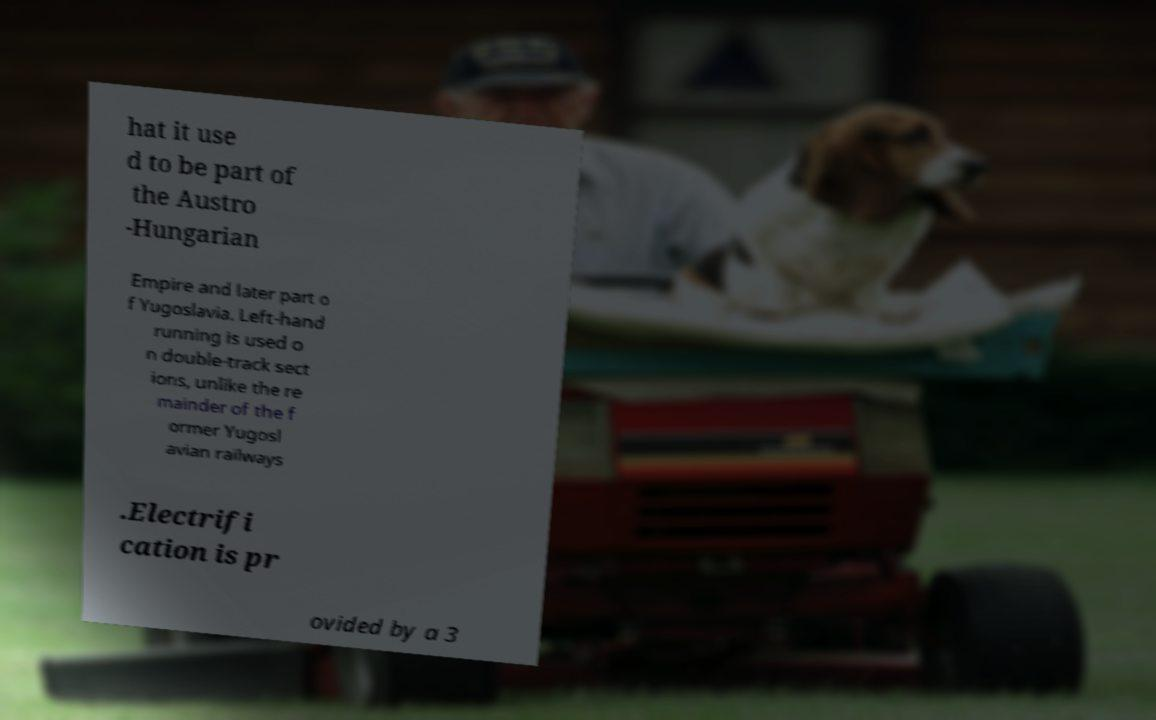For documentation purposes, I need the text within this image transcribed. Could you provide that? hat it use d to be part of the Austro -Hungarian Empire and later part o f Yugoslavia. Left-hand running is used o n double-track sect ions, unlike the re mainder of the f ormer Yugosl avian railways .Electrifi cation is pr ovided by a 3 